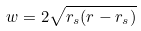<formula> <loc_0><loc_0><loc_500><loc_500>w = 2 \sqrt { r _ { s } ( r - r _ { s } ) }</formula> 